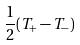<formula> <loc_0><loc_0><loc_500><loc_500>\frac { 1 } { 2 } ( T _ { + } - T _ { - } )</formula> 